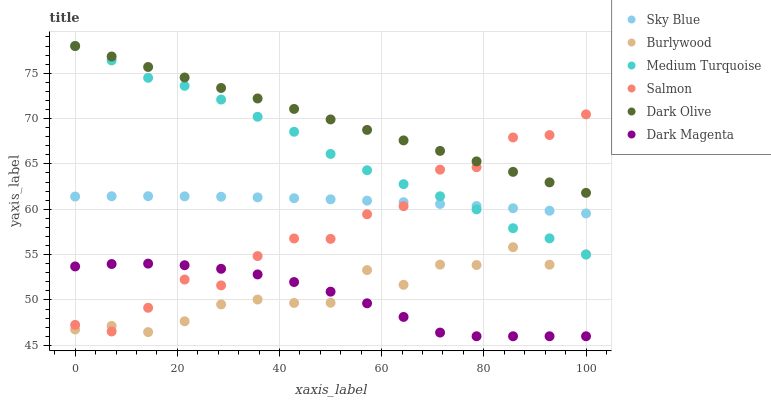Does Dark Magenta have the minimum area under the curve?
Answer yes or no. Yes. Does Dark Olive have the maximum area under the curve?
Answer yes or no. Yes. Does Burlywood have the minimum area under the curve?
Answer yes or no. No. Does Burlywood have the maximum area under the curve?
Answer yes or no. No. Is Dark Olive the smoothest?
Answer yes or no. Yes. Is Salmon the roughest?
Answer yes or no. Yes. Is Burlywood the smoothest?
Answer yes or no. No. Is Burlywood the roughest?
Answer yes or no. No. Does Dark Magenta have the lowest value?
Answer yes or no. Yes. Does Burlywood have the lowest value?
Answer yes or no. No. Does Medium Turquoise have the highest value?
Answer yes or no. Yes. Does Burlywood have the highest value?
Answer yes or no. No. Is Sky Blue less than Dark Olive?
Answer yes or no. Yes. Is Sky Blue greater than Burlywood?
Answer yes or no. Yes. Does Dark Olive intersect Salmon?
Answer yes or no. Yes. Is Dark Olive less than Salmon?
Answer yes or no. No. Is Dark Olive greater than Salmon?
Answer yes or no. No. Does Sky Blue intersect Dark Olive?
Answer yes or no. No. 